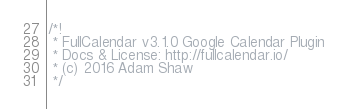<code> <loc_0><loc_0><loc_500><loc_500><_JavaScript_>/*!
 * FullCalendar v3.1.0 Google Calendar Plugin
 * Docs & License: http://fullcalendar.io/
 * (c) 2016 Adam Shaw
 */</code> 